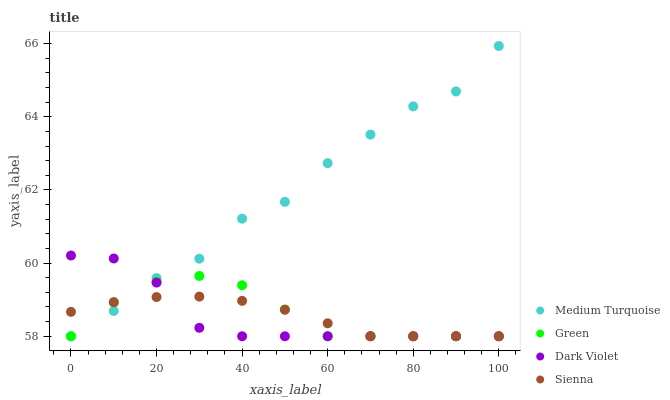Does Dark Violet have the minimum area under the curve?
Answer yes or no. Yes. Does Medium Turquoise have the maximum area under the curve?
Answer yes or no. Yes. Does Green have the minimum area under the curve?
Answer yes or no. No. Does Green have the maximum area under the curve?
Answer yes or no. No. Is Sienna the smoothest?
Answer yes or no. Yes. Is Medium Turquoise the roughest?
Answer yes or no. Yes. Is Green the smoothest?
Answer yes or no. No. Is Green the roughest?
Answer yes or no. No. Does Sienna have the lowest value?
Answer yes or no. Yes. Does Medium Turquoise have the highest value?
Answer yes or no. Yes. Does Green have the highest value?
Answer yes or no. No. Does Dark Violet intersect Green?
Answer yes or no. Yes. Is Dark Violet less than Green?
Answer yes or no. No. Is Dark Violet greater than Green?
Answer yes or no. No. 